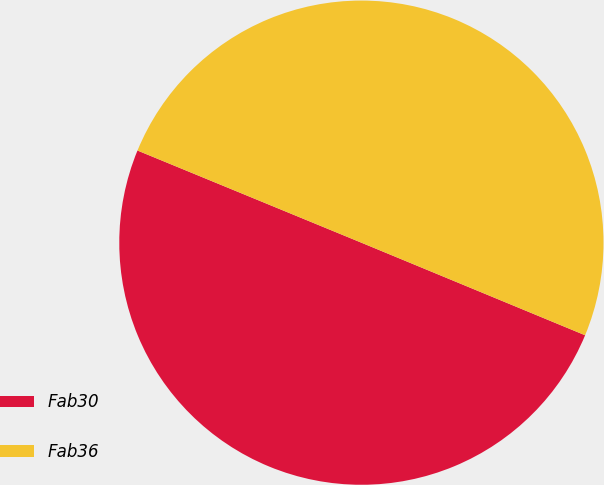<chart> <loc_0><loc_0><loc_500><loc_500><pie_chart><fcel>Fab30<fcel>Fab36<nl><fcel>49.97%<fcel>50.03%<nl></chart> 